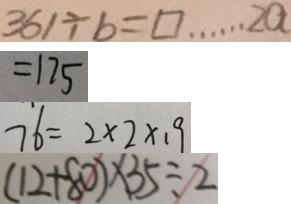Convert formula to latex. <formula><loc_0><loc_0><loc_500><loc_500>3 6 1 \div b = \square \cdots 2 a 
 = 1 7 5 
 7 6 = 2 \times 2 \times 1 9 
 ( 1 2 + 8 0 ) \times 3 5 \div 2</formula> 